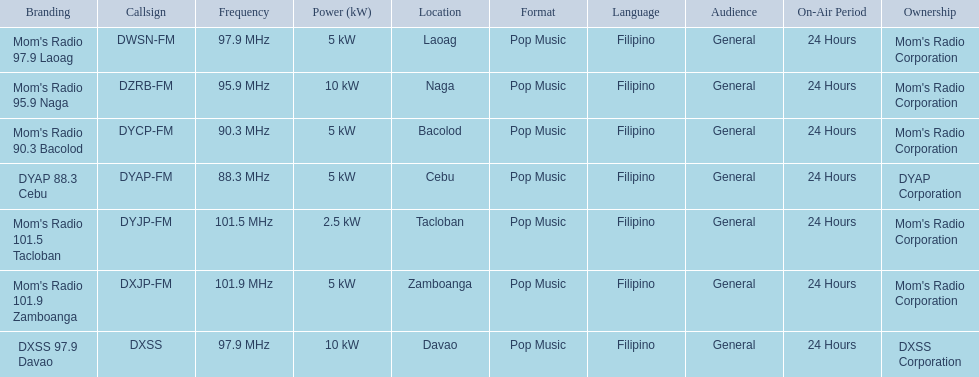What are all of the frequencies? 97.9 MHz, 95.9 MHz, 90.3 MHz, 88.3 MHz, 101.5 MHz, 101.9 MHz, 97.9 MHz. Which of these frequencies is the lowest? 88.3 MHz. Which branding does this frequency belong to? DYAP 88.3 Cebu. 